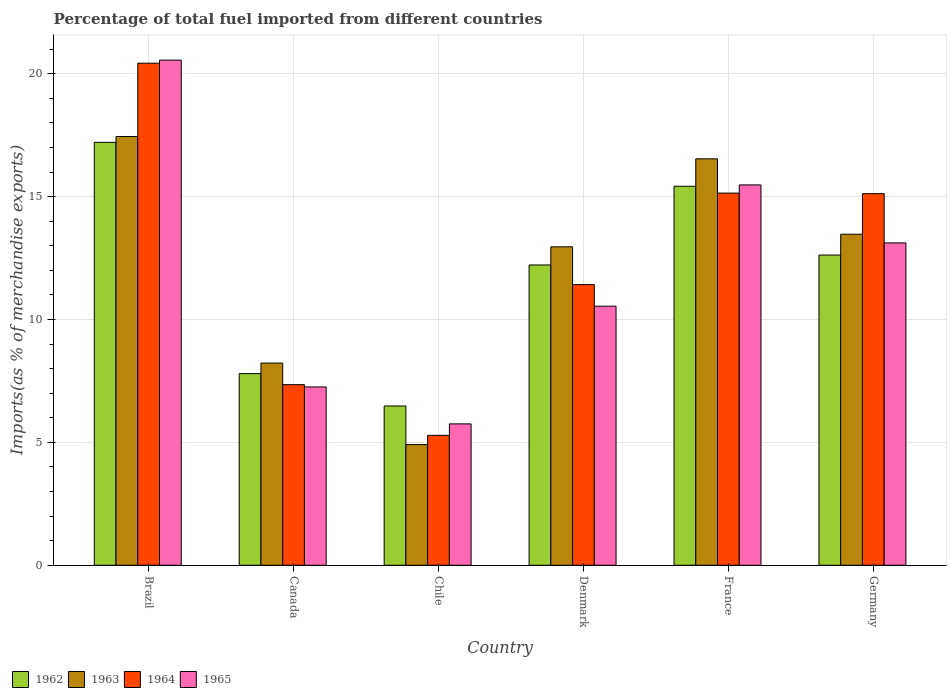Are the number of bars per tick equal to the number of legend labels?
Offer a terse response. Yes. Are the number of bars on each tick of the X-axis equal?
Ensure brevity in your answer.  Yes. How many bars are there on the 6th tick from the left?
Ensure brevity in your answer.  4. What is the label of the 1st group of bars from the left?
Your answer should be very brief. Brazil. In how many cases, is the number of bars for a given country not equal to the number of legend labels?
Your answer should be very brief. 0. What is the percentage of imports to different countries in 1964 in France?
Keep it short and to the point. 15.14. Across all countries, what is the maximum percentage of imports to different countries in 1965?
Provide a short and direct response. 20.55. Across all countries, what is the minimum percentage of imports to different countries in 1963?
Your response must be concise. 4.91. What is the total percentage of imports to different countries in 1964 in the graph?
Give a very brief answer. 74.75. What is the difference between the percentage of imports to different countries in 1965 in Brazil and that in Denmark?
Ensure brevity in your answer.  10.01. What is the difference between the percentage of imports to different countries in 1963 in Chile and the percentage of imports to different countries in 1965 in Brazil?
Your answer should be very brief. -15.64. What is the average percentage of imports to different countries in 1965 per country?
Make the answer very short. 12.12. What is the difference between the percentage of imports to different countries of/in 1965 and percentage of imports to different countries of/in 1962 in Canada?
Give a very brief answer. -0.54. In how many countries, is the percentage of imports to different countries in 1964 greater than 16 %?
Ensure brevity in your answer.  1. What is the ratio of the percentage of imports to different countries in 1962 in Brazil to that in Germany?
Offer a terse response. 1.36. What is the difference between the highest and the second highest percentage of imports to different countries in 1965?
Keep it short and to the point. 7.44. What is the difference between the highest and the lowest percentage of imports to different countries in 1963?
Ensure brevity in your answer.  12.54. In how many countries, is the percentage of imports to different countries in 1963 greater than the average percentage of imports to different countries in 1963 taken over all countries?
Provide a succinct answer. 4. Is it the case that in every country, the sum of the percentage of imports to different countries in 1963 and percentage of imports to different countries in 1962 is greater than the sum of percentage of imports to different countries in 1965 and percentage of imports to different countries in 1964?
Your answer should be compact. No. What does the 1st bar from the left in Brazil represents?
Provide a short and direct response. 1962. Are all the bars in the graph horizontal?
Offer a very short reply. No. Does the graph contain any zero values?
Your response must be concise. No. Does the graph contain grids?
Your answer should be very brief. Yes. What is the title of the graph?
Ensure brevity in your answer.  Percentage of total fuel imported from different countries. What is the label or title of the X-axis?
Your response must be concise. Country. What is the label or title of the Y-axis?
Your response must be concise. Imports(as % of merchandise exports). What is the Imports(as % of merchandise exports) of 1962 in Brazil?
Offer a very short reply. 17.21. What is the Imports(as % of merchandise exports) in 1963 in Brazil?
Provide a short and direct response. 17.45. What is the Imports(as % of merchandise exports) of 1964 in Brazil?
Your answer should be compact. 20.43. What is the Imports(as % of merchandise exports) of 1965 in Brazil?
Ensure brevity in your answer.  20.55. What is the Imports(as % of merchandise exports) of 1962 in Canada?
Give a very brief answer. 7.8. What is the Imports(as % of merchandise exports) of 1963 in Canada?
Offer a terse response. 8.23. What is the Imports(as % of merchandise exports) in 1964 in Canada?
Your answer should be compact. 7.35. What is the Imports(as % of merchandise exports) of 1965 in Canada?
Give a very brief answer. 7.26. What is the Imports(as % of merchandise exports) of 1962 in Chile?
Offer a terse response. 6.48. What is the Imports(as % of merchandise exports) of 1963 in Chile?
Your answer should be very brief. 4.91. What is the Imports(as % of merchandise exports) in 1964 in Chile?
Your response must be concise. 5.29. What is the Imports(as % of merchandise exports) of 1965 in Chile?
Provide a succinct answer. 5.75. What is the Imports(as % of merchandise exports) in 1962 in Denmark?
Keep it short and to the point. 12.22. What is the Imports(as % of merchandise exports) in 1963 in Denmark?
Your answer should be very brief. 12.96. What is the Imports(as % of merchandise exports) in 1964 in Denmark?
Keep it short and to the point. 11.42. What is the Imports(as % of merchandise exports) in 1965 in Denmark?
Ensure brevity in your answer.  10.54. What is the Imports(as % of merchandise exports) in 1962 in France?
Ensure brevity in your answer.  15.42. What is the Imports(as % of merchandise exports) of 1963 in France?
Give a very brief answer. 16.54. What is the Imports(as % of merchandise exports) in 1964 in France?
Provide a short and direct response. 15.14. What is the Imports(as % of merchandise exports) in 1965 in France?
Keep it short and to the point. 15.48. What is the Imports(as % of merchandise exports) in 1962 in Germany?
Your answer should be very brief. 12.62. What is the Imports(as % of merchandise exports) of 1963 in Germany?
Your answer should be very brief. 13.47. What is the Imports(as % of merchandise exports) of 1964 in Germany?
Offer a very short reply. 15.12. What is the Imports(as % of merchandise exports) of 1965 in Germany?
Give a very brief answer. 13.12. Across all countries, what is the maximum Imports(as % of merchandise exports) in 1962?
Your answer should be compact. 17.21. Across all countries, what is the maximum Imports(as % of merchandise exports) of 1963?
Offer a terse response. 17.45. Across all countries, what is the maximum Imports(as % of merchandise exports) in 1964?
Your answer should be compact. 20.43. Across all countries, what is the maximum Imports(as % of merchandise exports) of 1965?
Keep it short and to the point. 20.55. Across all countries, what is the minimum Imports(as % of merchandise exports) in 1962?
Offer a terse response. 6.48. Across all countries, what is the minimum Imports(as % of merchandise exports) of 1963?
Offer a terse response. 4.91. Across all countries, what is the minimum Imports(as % of merchandise exports) in 1964?
Offer a very short reply. 5.29. Across all countries, what is the minimum Imports(as % of merchandise exports) in 1965?
Your answer should be very brief. 5.75. What is the total Imports(as % of merchandise exports) in 1962 in the graph?
Offer a very short reply. 71.75. What is the total Imports(as % of merchandise exports) in 1963 in the graph?
Keep it short and to the point. 73.55. What is the total Imports(as % of merchandise exports) in 1964 in the graph?
Provide a succinct answer. 74.75. What is the total Imports(as % of merchandise exports) in 1965 in the graph?
Offer a very short reply. 72.7. What is the difference between the Imports(as % of merchandise exports) of 1962 in Brazil and that in Canada?
Your answer should be compact. 9.41. What is the difference between the Imports(as % of merchandise exports) in 1963 in Brazil and that in Canada?
Make the answer very short. 9.22. What is the difference between the Imports(as % of merchandise exports) of 1964 in Brazil and that in Canada?
Offer a terse response. 13.08. What is the difference between the Imports(as % of merchandise exports) in 1965 in Brazil and that in Canada?
Give a very brief answer. 13.3. What is the difference between the Imports(as % of merchandise exports) in 1962 in Brazil and that in Chile?
Your answer should be very brief. 10.73. What is the difference between the Imports(as % of merchandise exports) of 1963 in Brazil and that in Chile?
Provide a succinct answer. 12.54. What is the difference between the Imports(as % of merchandise exports) in 1964 in Brazil and that in Chile?
Offer a terse response. 15.14. What is the difference between the Imports(as % of merchandise exports) of 1965 in Brazil and that in Chile?
Offer a very short reply. 14.8. What is the difference between the Imports(as % of merchandise exports) in 1962 in Brazil and that in Denmark?
Your answer should be very brief. 4.99. What is the difference between the Imports(as % of merchandise exports) in 1963 in Brazil and that in Denmark?
Offer a terse response. 4.49. What is the difference between the Imports(as % of merchandise exports) in 1964 in Brazil and that in Denmark?
Your answer should be very brief. 9.01. What is the difference between the Imports(as % of merchandise exports) in 1965 in Brazil and that in Denmark?
Your answer should be compact. 10.01. What is the difference between the Imports(as % of merchandise exports) of 1962 in Brazil and that in France?
Ensure brevity in your answer.  1.79. What is the difference between the Imports(as % of merchandise exports) of 1963 in Brazil and that in France?
Offer a terse response. 0.91. What is the difference between the Imports(as % of merchandise exports) of 1964 in Brazil and that in France?
Provide a short and direct response. 5.29. What is the difference between the Imports(as % of merchandise exports) of 1965 in Brazil and that in France?
Keep it short and to the point. 5.08. What is the difference between the Imports(as % of merchandise exports) in 1962 in Brazil and that in Germany?
Provide a succinct answer. 4.59. What is the difference between the Imports(as % of merchandise exports) of 1963 in Brazil and that in Germany?
Give a very brief answer. 3.98. What is the difference between the Imports(as % of merchandise exports) in 1964 in Brazil and that in Germany?
Ensure brevity in your answer.  5.31. What is the difference between the Imports(as % of merchandise exports) of 1965 in Brazil and that in Germany?
Give a very brief answer. 7.44. What is the difference between the Imports(as % of merchandise exports) in 1962 in Canada and that in Chile?
Offer a very short reply. 1.32. What is the difference between the Imports(as % of merchandise exports) in 1963 in Canada and that in Chile?
Your response must be concise. 3.32. What is the difference between the Imports(as % of merchandise exports) in 1964 in Canada and that in Chile?
Your response must be concise. 2.06. What is the difference between the Imports(as % of merchandise exports) of 1965 in Canada and that in Chile?
Provide a short and direct response. 1.5. What is the difference between the Imports(as % of merchandise exports) of 1962 in Canada and that in Denmark?
Ensure brevity in your answer.  -4.42. What is the difference between the Imports(as % of merchandise exports) of 1963 in Canada and that in Denmark?
Make the answer very short. -4.73. What is the difference between the Imports(as % of merchandise exports) of 1964 in Canada and that in Denmark?
Your answer should be very brief. -4.07. What is the difference between the Imports(as % of merchandise exports) in 1965 in Canada and that in Denmark?
Make the answer very short. -3.29. What is the difference between the Imports(as % of merchandise exports) of 1962 in Canada and that in France?
Offer a very short reply. -7.62. What is the difference between the Imports(as % of merchandise exports) of 1963 in Canada and that in France?
Provide a succinct answer. -8.31. What is the difference between the Imports(as % of merchandise exports) of 1964 in Canada and that in France?
Offer a terse response. -7.79. What is the difference between the Imports(as % of merchandise exports) in 1965 in Canada and that in France?
Offer a very short reply. -8.22. What is the difference between the Imports(as % of merchandise exports) of 1962 in Canada and that in Germany?
Ensure brevity in your answer.  -4.82. What is the difference between the Imports(as % of merchandise exports) in 1963 in Canada and that in Germany?
Offer a terse response. -5.24. What is the difference between the Imports(as % of merchandise exports) in 1964 in Canada and that in Germany?
Offer a terse response. -7.77. What is the difference between the Imports(as % of merchandise exports) in 1965 in Canada and that in Germany?
Make the answer very short. -5.86. What is the difference between the Imports(as % of merchandise exports) of 1962 in Chile and that in Denmark?
Ensure brevity in your answer.  -5.74. What is the difference between the Imports(as % of merchandise exports) of 1963 in Chile and that in Denmark?
Your response must be concise. -8.05. What is the difference between the Imports(as % of merchandise exports) of 1964 in Chile and that in Denmark?
Your answer should be compact. -6.13. What is the difference between the Imports(as % of merchandise exports) in 1965 in Chile and that in Denmark?
Your answer should be very brief. -4.79. What is the difference between the Imports(as % of merchandise exports) in 1962 in Chile and that in France?
Offer a very short reply. -8.94. What is the difference between the Imports(as % of merchandise exports) in 1963 in Chile and that in France?
Your answer should be very brief. -11.63. What is the difference between the Imports(as % of merchandise exports) in 1964 in Chile and that in France?
Offer a very short reply. -9.86. What is the difference between the Imports(as % of merchandise exports) in 1965 in Chile and that in France?
Keep it short and to the point. -9.72. What is the difference between the Imports(as % of merchandise exports) in 1962 in Chile and that in Germany?
Offer a very short reply. -6.14. What is the difference between the Imports(as % of merchandise exports) of 1963 in Chile and that in Germany?
Your response must be concise. -8.56. What is the difference between the Imports(as % of merchandise exports) of 1964 in Chile and that in Germany?
Make the answer very short. -9.83. What is the difference between the Imports(as % of merchandise exports) of 1965 in Chile and that in Germany?
Provide a short and direct response. -7.36. What is the difference between the Imports(as % of merchandise exports) in 1962 in Denmark and that in France?
Offer a very short reply. -3.2. What is the difference between the Imports(as % of merchandise exports) of 1963 in Denmark and that in France?
Keep it short and to the point. -3.58. What is the difference between the Imports(as % of merchandise exports) in 1964 in Denmark and that in France?
Keep it short and to the point. -3.72. What is the difference between the Imports(as % of merchandise exports) of 1965 in Denmark and that in France?
Your response must be concise. -4.94. What is the difference between the Imports(as % of merchandise exports) in 1962 in Denmark and that in Germany?
Make the answer very short. -0.4. What is the difference between the Imports(as % of merchandise exports) of 1963 in Denmark and that in Germany?
Keep it short and to the point. -0.51. What is the difference between the Imports(as % of merchandise exports) of 1964 in Denmark and that in Germany?
Offer a terse response. -3.7. What is the difference between the Imports(as % of merchandise exports) of 1965 in Denmark and that in Germany?
Provide a succinct answer. -2.58. What is the difference between the Imports(as % of merchandise exports) in 1962 in France and that in Germany?
Your response must be concise. 2.8. What is the difference between the Imports(as % of merchandise exports) of 1963 in France and that in Germany?
Offer a very short reply. 3.07. What is the difference between the Imports(as % of merchandise exports) of 1964 in France and that in Germany?
Keep it short and to the point. 0.02. What is the difference between the Imports(as % of merchandise exports) of 1965 in France and that in Germany?
Your answer should be very brief. 2.36. What is the difference between the Imports(as % of merchandise exports) of 1962 in Brazil and the Imports(as % of merchandise exports) of 1963 in Canada?
Give a very brief answer. 8.98. What is the difference between the Imports(as % of merchandise exports) in 1962 in Brazil and the Imports(as % of merchandise exports) in 1964 in Canada?
Your answer should be compact. 9.86. What is the difference between the Imports(as % of merchandise exports) of 1962 in Brazil and the Imports(as % of merchandise exports) of 1965 in Canada?
Ensure brevity in your answer.  9.95. What is the difference between the Imports(as % of merchandise exports) of 1963 in Brazil and the Imports(as % of merchandise exports) of 1964 in Canada?
Your answer should be very brief. 10.1. What is the difference between the Imports(as % of merchandise exports) of 1963 in Brazil and the Imports(as % of merchandise exports) of 1965 in Canada?
Provide a succinct answer. 10.19. What is the difference between the Imports(as % of merchandise exports) of 1964 in Brazil and the Imports(as % of merchandise exports) of 1965 in Canada?
Provide a succinct answer. 13.17. What is the difference between the Imports(as % of merchandise exports) in 1962 in Brazil and the Imports(as % of merchandise exports) in 1963 in Chile?
Provide a succinct answer. 12.3. What is the difference between the Imports(as % of merchandise exports) of 1962 in Brazil and the Imports(as % of merchandise exports) of 1964 in Chile?
Keep it short and to the point. 11.92. What is the difference between the Imports(as % of merchandise exports) of 1962 in Brazil and the Imports(as % of merchandise exports) of 1965 in Chile?
Ensure brevity in your answer.  11.46. What is the difference between the Imports(as % of merchandise exports) of 1963 in Brazil and the Imports(as % of merchandise exports) of 1964 in Chile?
Ensure brevity in your answer.  12.16. What is the difference between the Imports(as % of merchandise exports) in 1963 in Brazil and the Imports(as % of merchandise exports) in 1965 in Chile?
Keep it short and to the point. 11.69. What is the difference between the Imports(as % of merchandise exports) of 1964 in Brazil and the Imports(as % of merchandise exports) of 1965 in Chile?
Offer a very short reply. 14.68. What is the difference between the Imports(as % of merchandise exports) of 1962 in Brazil and the Imports(as % of merchandise exports) of 1963 in Denmark?
Your response must be concise. 4.25. What is the difference between the Imports(as % of merchandise exports) of 1962 in Brazil and the Imports(as % of merchandise exports) of 1964 in Denmark?
Provide a short and direct response. 5.79. What is the difference between the Imports(as % of merchandise exports) in 1962 in Brazil and the Imports(as % of merchandise exports) in 1965 in Denmark?
Make the answer very short. 6.67. What is the difference between the Imports(as % of merchandise exports) in 1963 in Brazil and the Imports(as % of merchandise exports) in 1964 in Denmark?
Your response must be concise. 6.03. What is the difference between the Imports(as % of merchandise exports) of 1963 in Brazil and the Imports(as % of merchandise exports) of 1965 in Denmark?
Keep it short and to the point. 6.91. What is the difference between the Imports(as % of merchandise exports) in 1964 in Brazil and the Imports(as % of merchandise exports) in 1965 in Denmark?
Provide a succinct answer. 9.89. What is the difference between the Imports(as % of merchandise exports) of 1962 in Brazil and the Imports(as % of merchandise exports) of 1963 in France?
Give a very brief answer. 0.67. What is the difference between the Imports(as % of merchandise exports) in 1962 in Brazil and the Imports(as % of merchandise exports) in 1964 in France?
Offer a very short reply. 2.07. What is the difference between the Imports(as % of merchandise exports) of 1962 in Brazil and the Imports(as % of merchandise exports) of 1965 in France?
Ensure brevity in your answer.  1.73. What is the difference between the Imports(as % of merchandise exports) in 1963 in Brazil and the Imports(as % of merchandise exports) in 1964 in France?
Ensure brevity in your answer.  2.3. What is the difference between the Imports(as % of merchandise exports) of 1963 in Brazil and the Imports(as % of merchandise exports) of 1965 in France?
Your answer should be compact. 1.97. What is the difference between the Imports(as % of merchandise exports) in 1964 in Brazil and the Imports(as % of merchandise exports) in 1965 in France?
Keep it short and to the point. 4.95. What is the difference between the Imports(as % of merchandise exports) in 1962 in Brazil and the Imports(as % of merchandise exports) in 1963 in Germany?
Make the answer very short. 3.74. What is the difference between the Imports(as % of merchandise exports) of 1962 in Brazil and the Imports(as % of merchandise exports) of 1964 in Germany?
Give a very brief answer. 2.09. What is the difference between the Imports(as % of merchandise exports) of 1962 in Brazil and the Imports(as % of merchandise exports) of 1965 in Germany?
Your answer should be very brief. 4.09. What is the difference between the Imports(as % of merchandise exports) in 1963 in Brazil and the Imports(as % of merchandise exports) in 1964 in Germany?
Ensure brevity in your answer.  2.33. What is the difference between the Imports(as % of merchandise exports) of 1963 in Brazil and the Imports(as % of merchandise exports) of 1965 in Germany?
Offer a terse response. 4.33. What is the difference between the Imports(as % of merchandise exports) of 1964 in Brazil and the Imports(as % of merchandise exports) of 1965 in Germany?
Ensure brevity in your answer.  7.31. What is the difference between the Imports(as % of merchandise exports) in 1962 in Canada and the Imports(as % of merchandise exports) in 1963 in Chile?
Make the answer very short. 2.89. What is the difference between the Imports(as % of merchandise exports) in 1962 in Canada and the Imports(as % of merchandise exports) in 1964 in Chile?
Ensure brevity in your answer.  2.51. What is the difference between the Imports(as % of merchandise exports) of 1962 in Canada and the Imports(as % of merchandise exports) of 1965 in Chile?
Provide a succinct answer. 2.04. What is the difference between the Imports(as % of merchandise exports) of 1963 in Canada and the Imports(as % of merchandise exports) of 1964 in Chile?
Make the answer very short. 2.94. What is the difference between the Imports(as % of merchandise exports) of 1963 in Canada and the Imports(as % of merchandise exports) of 1965 in Chile?
Your answer should be very brief. 2.48. What is the difference between the Imports(as % of merchandise exports) of 1964 in Canada and the Imports(as % of merchandise exports) of 1965 in Chile?
Your answer should be very brief. 1.6. What is the difference between the Imports(as % of merchandise exports) of 1962 in Canada and the Imports(as % of merchandise exports) of 1963 in Denmark?
Provide a short and direct response. -5.16. What is the difference between the Imports(as % of merchandise exports) of 1962 in Canada and the Imports(as % of merchandise exports) of 1964 in Denmark?
Give a very brief answer. -3.62. What is the difference between the Imports(as % of merchandise exports) in 1962 in Canada and the Imports(as % of merchandise exports) in 1965 in Denmark?
Provide a succinct answer. -2.74. What is the difference between the Imports(as % of merchandise exports) in 1963 in Canada and the Imports(as % of merchandise exports) in 1964 in Denmark?
Make the answer very short. -3.19. What is the difference between the Imports(as % of merchandise exports) of 1963 in Canada and the Imports(as % of merchandise exports) of 1965 in Denmark?
Keep it short and to the point. -2.31. What is the difference between the Imports(as % of merchandise exports) of 1964 in Canada and the Imports(as % of merchandise exports) of 1965 in Denmark?
Keep it short and to the point. -3.19. What is the difference between the Imports(as % of merchandise exports) in 1962 in Canada and the Imports(as % of merchandise exports) in 1963 in France?
Provide a short and direct response. -8.74. What is the difference between the Imports(as % of merchandise exports) of 1962 in Canada and the Imports(as % of merchandise exports) of 1964 in France?
Offer a very short reply. -7.35. What is the difference between the Imports(as % of merchandise exports) of 1962 in Canada and the Imports(as % of merchandise exports) of 1965 in France?
Give a very brief answer. -7.68. What is the difference between the Imports(as % of merchandise exports) in 1963 in Canada and the Imports(as % of merchandise exports) in 1964 in France?
Your answer should be compact. -6.91. What is the difference between the Imports(as % of merchandise exports) in 1963 in Canada and the Imports(as % of merchandise exports) in 1965 in France?
Give a very brief answer. -7.25. What is the difference between the Imports(as % of merchandise exports) of 1964 in Canada and the Imports(as % of merchandise exports) of 1965 in France?
Provide a succinct answer. -8.13. What is the difference between the Imports(as % of merchandise exports) in 1962 in Canada and the Imports(as % of merchandise exports) in 1963 in Germany?
Make the answer very short. -5.67. What is the difference between the Imports(as % of merchandise exports) in 1962 in Canada and the Imports(as % of merchandise exports) in 1964 in Germany?
Ensure brevity in your answer.  -7.32. What is the difference between the Imports(as % of merchandise exports) of 1962 in Canada and the Imports(as % of merchandise exports) of 1965 in Germany?
Keep it short and to the point. -5.32. What is the difference between the Imports(as % of merchandise exports) of 1963 in Canada and the Imports(as % of merchandise exports) of 1964 in Germany?
Keep it short and to the point. -6.89. What is the difference between the Imports(as % of merchandise exports) of 1963 in Canada and the Imports(as % of merchandise exports) of 1965 in Germany?
Keep it short and to the point. -4.89. What is the difference between the Imports(as % of merchandise exports) of 1964 in Canada and the Imports(as % of merchandise exports) of 1965 in Germany?
Make the answer very short. -5.77. What is the difference between the Imports(as % of merchandise exports) of 1962 in Chile and the Imports(as % of merchandise exports) of 1963 in Denmark?
Keep it short and to the point. -6.48. What is the difference between the Imports(as % of merchandise exports) in 1962 in Chile and the Imports(as % of merchandise exports) in 1964 in Denmark?
Ensure brevity in your answer.  -4.94. What is the difference between the Imports(as % of merchandise exports) in 1962 in Chile and the Imports(as % of merchandise exports) in 1965 in Denmark?
Your answer should be compact. -4.06. What is the difference between the Imports(as % of merchandise exports) of 1963 in Chile and the Imports(as % of merchandise exports) of 1964 in Denmark?
Make the answer very short. -6.51. What is the difference between the Imports(as % of merchandise exports) in 1963 in Chile and the Imports(as % of merchandise exports) in 1965 in Denmark?
Offer a very short reply. -5.63. What is the difference between the Imports(as % of merchandise exports) of 1964 in Chile and the Imports(as % of merchandise exports) of 1965 in Denmark?
Make the answer very short. -5.25. What is the difference between the Imports(as % of merchandise exports) in 1962 in Chile and the Imports(as % of merchandise exports) in 1963 in France?
Your answer should be compact. -10.06. What is the difference between the Imports(as % of merchandise exports) in 1962 in Chile and the Imports(as % of merchandise exports) in 1964 in France?
Provide a succinct answer. -8.66. What is the difference between the Imports(as % of merchandise exports) of 1962 in Chile and the Imports(as % of merchandise exports) of 1965 in France?
Your response must be concise. -9. What is the difference between the Imports(as % of merchandise exports) of 1963 in Chile and the Imports(as % of merchandise exports) of 1964 in France?
Provide a short and direct response. -10.23. What is the difference between the Imports(as % of merchandise exports) in 1963 in Chile and the Imports(as % of merchandise exports) in 1965 in France?
Make the answer very short. -10.57. What is the difference between the Imports(as % of merchandise exports) in 1964 in Chile and the Imports(as % of merchandise exports) in 1965 in France?
Offer a terse response. -10.19. What is the difference between the Imports(as % of merchandise exports) of 1962 in Chile and the Imports(as % of merchandise exports) of 1963 in Germany?
Your answer should be very brief. -6.99. What is the difference between the Imports(as % of merchandise exports) of 1962 in Chile and the Imports(as % of merchandise exports) of 1964 in Germany?
Your answer should be compact. -8.64. What is the difference between the Imports(as % of merchandise exports) in 1962 in Chile and the Imports(as % of merchandise exports) in 1965 in Germany?
Offer a very short reply. -6.64. What is the difference between the Imports(as % of merchandise exports) in 1963 in Chile and the Imports(as % of merchandise exports) in 1964 in Germany?
Your response must be concise. -10.21. What is the difference between the Imports(as % of merchandise exports) in 1963 in Chile and the Imports(as % of merchandise exports) in 1965 in Germany?
Give a very brief answer. -8.21. What is the difference between the Imports(as % of merchandise exports) in 1964 in Chile and the Imports(as % of merchandise exports) in 1965 in Germany?
Provide a short and direct response. -7.83. What is the difference between the Imports(as % of merchandise exports) in 1962 in Denmark and the Imports(as % of merchandise exports) in 1963 in France?
Your answer should be compact. -4.32. What is the difference between the Imports(as % of merchandise exports) of 1962 in Denmark and the Imports(as % of merchandise exports) of 1964 in France?
Offer a terse response. -2.92. What is the difference between the Imports(as % of merchandise exports) in 1962 in Denmark and the Imports(as % of merchandise exports) in 1965 in France?
Give a very brief answer. -3.26. What is the difference between the Imports(as % of merchandise exports) of 1963 in Denmark and the Imports(as % of merchandise exports) of 1964 in France?
Your answer should be very brief. -2.19. What is the difference between the Imports(as % of merchandise exports) of 1963 in Denmark and the Imports(as % of merchandise exports) of 1965 in France?
Provide a short and direct response. -2.52. What is the difference between the Imports(as % of merchandise exports) in 1964 in Denmark and the Imports(as % of merchandise exports) in 1965 in France?
Your response must be concise. -4.06. What is the difference between the Imports(as % of merchandise exports) in 1962 in Denmark and the Imports(as % of merchandise exports) in 1963 in Germany?
Ensure brevity in your answer.  -1.25. What is the difference between the Imports(as % of merchandise exports) of 1962 in Denmark and the Imports(as % of merchandise exports) of 1964 in Germany?
Your answer should be compact. -2.9. What is the difference between the Imports(as % of merchandise exports) of 1962 in Denmark and the Imports(as % of merchandise exports) of 1965 in Germany?
Your response must be concise. -0.9. What is the difference between the Imports(as % of merchandise exports) in 1963 in Denmark and the Imports(as % of merchandise exports) in 1964 in Germany?
Your answer should be very brief. -2.16. What is the difference between the Imports(as % of merchandise exports) of 1963 in Denmark and the Imports(as % of merchandise exports) of 1965 in Germany?
Ensure brevity in your answer.  -0.16. What is the difference between the Imports(as % of merchandise exports) in 1964 in Denmark and the Imports(as % of merchandise exports) in 1965 in Germany?
Make the answer very short. -1.7. What is the difference between the Imports(as % of merchandise exports) in 1962 in France and the Imports(as % of merchandise exports) in 1963 in Germany?
Keep it short and to the point. 1.95. What is the difference between the Imports(as % of merchandise exports) of 1962 in France and the Imports(as % of merchandise exports) of 1964 in Germany?
Ensure brevity in your answer.  0.3. What is the difference between the Imports(as % of merchandise exports) in 1962 in France and the Imports(as % of merchandise exports) in 1965 in Germany?
Offer a terse response. 2.31. What is the difference between the Imports(as % of merchandise exports) of 1963 in France and the Imports(as % of merchandise exports) of 1964 in Germany?
Provide a short and direct response. 1.42. What is the difference between the Imports(as % of merchandise exports) in 1963 in France and the Imports(as % of merchandise exports) in 1965 in Germany?
Make the answer very short. 3.42. What is the difference between the Imports(as % of merchandise exports) of 1964 in France and the Imports(as % of merchandise exports) of 1965 in Germany?
Your answer should be very brief. 2.03. What is the average Imports(as % of merchandise exports) of 1962 per country?
Offer a terse response. 11.96. What is the average Imports(as % of merchandise exports) of 1963 per country?
Your response must be concise. 12.26. What is the average Imports(as % of merchandise exports) of 1964 per country?
Your response must be concise. 12.46. What is the average Imports(as % of merchandise exports) in 1965 per country?
Your answer should be very brief. 12.12. What is the difference between the Imports(as % of merchandise exports) of 1962 and Imports(as % of merchandise exports) of 1963 in Brazil?
Offer a terse response. -0.24. What is the difference between the Imports(as % of merchandise exports) in 1962 and Imports(as % of merchandise exports) in 1964 in Brazil?
Give a very brief answer. -3.22. What is the difference between the Imports(as % of merchandise exports) in 1962 and Imports(as % of merchandise exports) in 1965 in Brazil?
Your answer should be very brief. -3.35. What is the difference between the Imports(as % of merchandise exports) of 1963 and Imports(as % of merchandise exports) of 1964 in Brazil?
Provide a succinct answer. -2.98. What is the difference between the Imports(as % of merchandise exports) of 1963 and Imports(as % of merchandise exports) of 1965 in Brazil?
Your answer should be compact. -3.11. What is the difference between the Imports(as % of merchandise exports) in 1964 and Imports(as % of merchandise exports) in 1965 in Brazil?
Provide a short and direct response. -0.12. What is the difference between the Imports(as % of merchandise exports) of 1962 and Imports(as % of merchandise exports) of 1963 in Canada?
Make the answer very short. -0.43. What is the difference between the Imports(as % of merchandise exports) of 1962 and Imports(as % of merchandise exports) of 1964 in Canada?
Offer a terse response. 0.45. What is the difference between the Imports(as % of merchandise exports) of 1962 and Imports(as % of merchandise exports) of 1965 in Canada?
Offer a very short reply. 0.54. What is the difference between the Imports(as % of merchandise exports) of 1963 and Imports(as % of merchandise exports) of 1964 in Canada?
Give a very brief answer. 0.88. What is the difference between the Imports(as % of merchandise exports) of 1963 and Imports(as % of merchandise exports) of 1965 in Canada?
Provide a short and direct response. 0.97. What is the difference between the Imports(as % of merchandise exports) in 1964 and Imports(as % of merchandise exports) in 1965 in Canada?
Offer a terse response. 0.09. What is the difference between the Imports(as % of merchandise exports) in 1962 and Imports(as % of merchandise exports) in 1963 in Chile?
Your answer should be very brief. 1.57. What is the difference between the Imports(as % of merchandise exports) in 1962 and Imports(as % of merchandise exports) in 1964 in Chile?
Your answer should be compact. 1.19. What is the difference between the Imports(as % of merchandise exports) of 1962 and Imports(as % of merchandise exports) of 1965 in Chile?
Offer a very short reply. 0.73. What is the difference between the Imports(as % of merchandise exports) of 1963 and Imports(as % of merchandise exports) of 1964 in Chile?
Offer a very short reply. -0.38. What is the difference between the Imports(as % of merchandise exports) in 1963 and Imports(as % of merchandise exports) in 1965 in Chile?
Give a very brief answer. -0.84. What is the difference between the Imports(as % of merchandise exports) of 1964 and Imports(as % of merchandise exports) of 1965 in Chile?
Your answer should be compact. -0.47. What is the difference between the Imports(as % of merchandise exports) of 1962 and Imports(as % of merchandise exports) of 1963 in Denmark?
Make the answer very short. -0.74. What is the difference between the Imports(as % of merchandise exports) of 1962 and Imports(as % of merchandise exports) of 1964 in Denmark?
Ensure brevity in your answer.  0.8. What is the difference between the Imports(as % of merchandise exports) of 1962 and Imports(as % of merchandise exports) of 1965 in Denmark?
Keep it short and to the point. 1.68. What is the difference between the Imports(as % of merchandise exports) in 1963 and Imports(as % of merchandise exports) in 1964 in Denmark?
Your answer should be compact. 1.54. What is the difference between the Imports(as % of merchandise exports) of 1963 and Imports(as % of merchandise exports) of 1965 in Denmark?
Keep it short and to the point. 2.42. What is the difference between the Imports(as % of merchandise exports) of 1964 and Imports(as % of merchandise exports) of 1965 in Denmark?
Make the answer very short. 0.88. What is the difference between the Imports(as % of merchandise exports) of 1962 and Imports(as % of merchandise exports) of 1963 in France?
Provide a short and direct response. -1.12. What is the difference between the Imports(as % of merchandise exports) of 1962 and Imports(as % of merchandise exports) of 1964 in France?
Offer a very short reply. 0.28. What is the difference between the Imports(as % of merchandise exports) in 1962 and Imports(as % of merchandise exports) in 1965 in France?
Your answer should be compact. -0.05. What is the difference between the Imports(as % of merchandise exports) in 1963 and Imports(as % of merchandise exports) in 1964 in France?
Provide a short and direct response. 1.39. What is the difference between the Imports(as % of merchandise exports) of 1963 and Imports(as % of merchandise exports) of 1965 in France?
Give a very brief answer. 1.06. What is the difference between the Imports(as % of merchandise exports) of 1964 and Imports(as % of merchandise exports) of 1965 in France?
Provide a short and direct response. -0.33. What is the difference between the Imports(as % of merchandise exports) in 1962 and Imports(as % of merchandise exports) in 1963 in Germany?
Provide a short and direct response. -0.85. What is the difference between the Imports(as % of merchandise exports) of 1962 and Imports(as % of merchandise exports) of 1964 in Germany?
Your answer should be very brief. -2.5. What is the difference between the Imports(as % of merchandise exports) of 1962 and Imports(as % of merchandise exports) of 1965 in Germany?
Offer a very short reply. -0.49. What is the difference between the Imports(as % of merchandise exports) in 1963 and Imports(as % of merchandise exports) in 1964 in Germany?
Give a very brief answer. -1.65. What is the difference between the Imports(as % of merchandise exports) of 1963 and Imports(as % of merchandise exports) of 1965 in Germany?
Your answer should be very brief. 0.35. What is the difference between the Imports(as % of merchandise exports) of 1964 and Imports(as % of merchandise exports) of 1965 in Germany?
Ensure brevity in your answer.  2. What is the ratio of the Imports(as % of merchandise exports) of 1962 in Brazil to that in Canada?
Provide a short and direct response. 2.21. What is the ratio of the Imports(as % of merchandise exports) of 1963 in Brazil to that in Canada?
Your answer should be very brief. 2.12. What is the ratio of the Imports(as % of merchandise exports) of 1964 in Brazil to that in Canada?
Your response must be concise. 2.78. What is the ratio of the Imports(as % of merchandise exports) of 1965 in Brazil to that in Canada?
Ensure brevity in your answer.  2.83. What is the ratio of the Imports(as % of merchandise exports) of 1962 in Brazil to that in Chile?
Provide a succinct answer. 2.65. What is the ratio of the Imports(as % of merchandise exports) in 1963 in Brazil to that in Chile?
Give a very brief answer. 3.55. What is the ratio of the Imports(as % of merchandise exports) in 1964 in Brazil to that in Chile?
Offer a very short reply. 3.86. What is the ratio of the Imports(as % of merchandise exports) in 1965 in Brazil to that in Chile?
Ensure brevity in your answer.  3.57. What is the ratio of the Imports(as % of merchandise exports) in 1962 in Brazil to that in Denmark?
Make the answer very short. 1.41. What is the ratio of the Imports(as % of merchandise exports) of 1963 in Brazil to that in Denmark?
Offer a very short reply. 1.35. What is the ratio of the Imports(as % of merchandise exports) in 1964 in Brazil to that in Denmark?
Make the answer very short. 1.79. What is the ratio of the Imports(as % of merchandise exports) in 1965 in Brazil to that in Denmark?
Ensure brevity in your answer.  1.95. What is the ratio of the Imports(as % of merchandise exports) of 1962 in Brazil to that in France?
Ensure brevity in your answer.  1.12. What is the ratio of the Imports(as % of merchandise exports) in 1963 in Brazil to that in France?
Provide a succinct answer. 1.05. What is the ratio of the Imports(as % of merchandise exports) of 1964 in Brazil to that in France?
Your response must be concise. 1.35. What is the ratio of the Imports(as % of merchandise exports) in 1965 in Brazil to that in France?
Give a very brief answer. 1.33. What is the ratio of the Imports(as % of merchandise exports) of 1962 in Brazil to that in Germany?
Offer a terse response. 1.36. What is the ratio of the Imports(as % of merchandise exports) of 1963 in Brazil to that in Germany?
Your answer should be very brief. 1.3. What is the ratio of the Imports(as % of merchandise exports) of 1964 in Brazil to that in Germany?
Ensure brevity in your answer.  1.35. What is the ratio of the Imports(as % of merchandise exports) of 1965 in Brazil to that in Germany?
Offer a terse response. 1.57. What is the ratio of the Imports(as % of merchandise exports) of 1962 in Canada to that in Chile?
Your answer should be compact. 1.2. What is the ratio of the Imports(as % of merchandise exports) in 1963 in Canada to that in Chile?
Make the answer very short. 1.68. What is the ratio of the Imports(as % of merchandise exports) in 1964 in Canada to that in Chile?
Provide a short and direct response. 1.39. What is the ratio of the Imports(as % of merchandise exports) in 1965 in Canada to that in Chile?
Offer a terse response. 1.26. What is the ratio of the Imports(as % of merchandise exports) in 1962 in Canada to that in Denmark?
Offer a terse response. 0.64. What is the ratio of the Imports(as % of merchandise exports) of 1963 in Canada to that in Denmark?
Your answer should be very brief. 0.64. What is the ratio of the Imports(as % of merchandise exports) in 1964 in Canada to that in Denmark?
Your answer should be very brief. 0.64. What is the ratio of the Imports(as % of merchandise exports) of 1965 in Canada to that in Denmark?
Provide a short and direct response. 0.69. What is the ratio of the Imports(as % of merchandise exports) of 1962 in Canada to that in France?
Offer a very short reply. 0.51. What is the ratio of the Imports(as % of merchandise exports) in 1963 in Canada to that in France?
Offer a terse response. 0.5. What is the ratio of the Imports(as % of merchandise exports) in 1964 in Canada to that in France?
Your response must be concise. 0.49. What is the ratio of the Imports(as % of merchandise exports) of 1965 in Canada to that in France?
Offer a terse response. 0.47. What is the ratio of the Imports(as % of merchandise exports) of 1962 in Canada to that in Germany?
Give a very brief answer. 0.62. What is the ratio of the Imports(as % of merchandise exports) of 1963 in Canada to that in Germany?
Your response must be concise. 0.61. What is the ratio of the Imports(as % of merchandise exports) of 1964 in Canada to that in Germany?
Offer a very short reply. 0.49. What is the ratio of the Imports(as % of merchandise exports) of 1965 in Canada to that in Germany?
Provide a succinct answer. 0.55. What is the ratio of the Imports(as % of merchandise exports) in 1962 in Chile to that in Denmark?
Your response must be concise. 0.53. What is the ratio of the Imports(as % of merchandise exports) of 1963 in Chile to that in Denmark?
Your response must be concise. 0.38. What is the ratio of the Imports(as % of merchandise exports) of 1964 in Chile to that in Denmark?
Give a very brief answer. 0.46. What is the ratio of the Imports(as % of merchandise exports) in 1965 in Chile to that in Denmark?
Make the answer very short. 0.55. What is the ratio of the Imports(as % of merchandise exports) of 1962 in Chile to that in France?
Make the answer very short. 0.42. What is the ratio of the Imports(as % of merchandise exports) of 1963 in Chile to that in France?
Provide a short and direct response. 0.3. What is the ratio of the Imports(as % of merchandise exports) in 1964 in Chile to that in France?
Ensure brevity in your answer.  0.35. What is the ratio of the Imports(as % of merchandise exports) of 1965 in Chile to that in France?
Provide a succinct answer. 0.37. What is the ratio of the Imports(as % of merchandise exports) of 1962 in Chile to that in Germany?
Offer a very short reply. 0.51. What is the ratio of the Imports(as % of merchandise exports) of 1963 in Chile to that in Germany?
Provide a succinct answer. 0.36. What is the ratio of the Imports(as % of merchandise exports) of 1964 in Chile to that in Germany?
Offer a terse response. 0.35. What is the ratio of the Imports(as % of merchandise exports) of 1965 in Chile to that in Germany?
Your response must be concise. 0.44. What is the ratio of the Imports(as % of merchandise exports) of 1962 in Denmark to that in France?
Give a very brief answer. 0.79. What is the ratio of the Imports(as % of merchandise exports) in 1963 in Denmark to that in France?
Provide a succinct answer. 0.78. What is the ratio of the Imports(as % of merchandise exports) of 1964 in Denmark to that in France?
Provide a short and direct response. 0.75. What is the ratio of the Imports(as % of merchandise exports) in 1965 in Denmark to that in France?
Offer a terse response. 0.68. What is the ratio of the Imports(as % of merchandise exports) of 1962 in Denmark to that in Germany?
Your response must be concise. 0.97. What is the ratio of the Imports(as % of merchandise exports) in 1963 in Denmark to that in Germany?
Your response must be concise. 0.96. What is the ratio of the Imports(as % of merchandise exports) of 1964 in Denmark to that in Germany?
Offer a very short reply. 0.76. What is the ratio of the Imports(as % of merchandise exports) of 1965 in Denmark to that in Germany?
Provide a succinct answer. 0.8. What is the ratio of the Imports(as % of merchandise exports) of 1962 in France to that in Germany?
Offer a very short reply. 1.22. What is the ratio of the Imports(as % of merchandise exports) of 1963 in France to that in Germany?
Your answer should be compact. 1.23. What is the ratio of the Imports(as % of merchandise exports) of 1965 in France to that in Germany?
Offer a very short reply. 1.18. What is the difference between the highest and the second highest Imports(as % of merchandise exports) in 1962?
Provide a succinct answer. 1.79. What is the difference between the highest and the second highest Imports(as % of merchandise exports) of 1963?
Keep it short and to the point. 0.91. What is the difference between the highest and the second highest Imports(as % of merchandise exports) of 1964?
Give a very brief answer. 5.29. What is the difference between the highest and the second highest Imports(as % of merchandise exports) of 1965?
Keep it short and to the point. 5.08. What is the difference between the highest and the lowest Imports(as % of merchandise exports) in 1962?
Your answer should be very brief. 10.73. What is the difference between the highest and the lowest Imports(as % of merchandise exports) of 1963?
Provide a succinct answer. 12.54. What is the difference between the highest and the lowest Imports(as % of merchandise exports) in 1964?
Your response must be concise. 15.14. What is the difference between the highest and the lowest Imports(as % of merchandise exports) in 1965?
Your answer should be very brief. 14.8. 